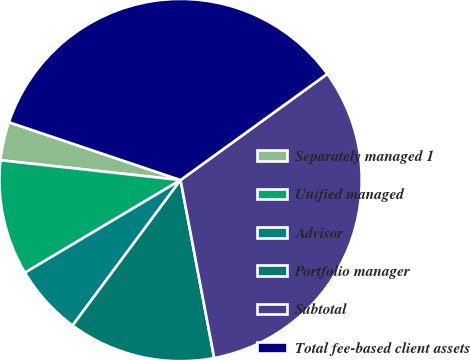Convert chart. <chart><loc_0><loc_0><loc_500><loc_500><pie_chart><fcel>Separately managed 1<fcel>Unified managed<fcel>Advisor<fcel>Portfolio manager<fcel>Subtotal<fcel>Total fee-based client assets<nl><fcel>3.43%<fcel>10.29%<fcel>6.29%<fcel>13.14%<fcel>32.0%<fcel>34.86%<nl></chart> 